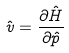Convert formula to latex. <formula><loc_0><loc_0><loc_500><loc_500>\hat { v } = \frac { \partial \hat { H } } { \partial \hat { p } }</formula> 